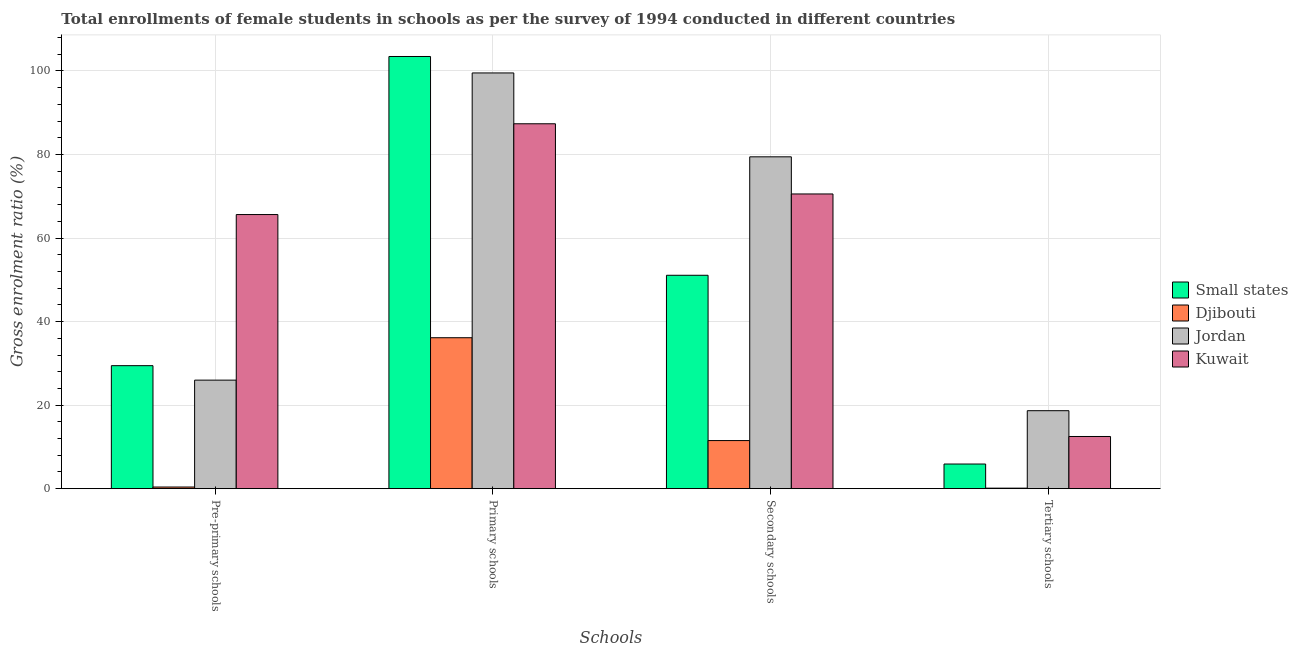How many different coloured bars are there?
Your response must be concise. 4. How many groups of bars are there?
Your response must be concise. 4. Are the number of bars on each tick of the X-axis equal?
Keep it short and to the point. Yes. What is the label of the 2nd group of bars from the left?
Your answer should be very brief. Primary schools. What is the gross enrolment ratio(female) in secondary schools in Kuwait?
Your response must be concise. 70.55. Across all countries, what is the maximum gross enrolment ratio(female) in primary schools?
Give a very brief answer. 103.46. Across all countries, what is the minimum gross enrolment ratio(female) in primary schools?
Ensure brevity in your answer.  36.14. In which country was the gross enrolment ratio(female) in tertiary schools maximum?
Give a very brief answer. Jordan. In which country was the gross enrolment ratio(female) in tertiary schools minimum?
Offer a very short reply. Djibouti. What is the total gross enrolment ratio(female) in pre-primary schools in the graph?
Offer a terse response. 121.45. What is the difference between the gross enrolment ratio(female) in secondary schools in Jordan and that in Kuwait?
Provide a short and direct response. 8.89. What is the difference between the gross enrolment ratio(female) in pre-primary schools in Small states and the gross enrolment ratio(female) in secondary schools in Kuwait?
Ensure brevity in your answer.  -41.11. What is the average gross enrolment ratio(female) in pre-primary schools per country?
Offer a terse response. 30.36. What is the difference between the gross enrolment ratio(female) in pre-primary schools and gross enrolment ratio(female) in secondary schools in Djibouti?
Give a very brief answer. -11.12. What is the ratio of the gross enrolment ratio(female) in primary schools in Kuwait to that in Small states?
Keep it short and to the point. 0.84. Is the gross enrolment ratio(female) in primary schools in Kuwait less than that in Djibouti?
Give a very brief answer. No. Is the difference between the gross enrolment ratio(female) in tertiary schools in Kuwait and Djibouti greater than the difference between the gross enrolment ratio(female) in pre-primary schools in Kuwait and Djibouti?
Your answer should be very brief. No. What is the difference between the highest and the second highest gross enrolment ratio(female) in tertiary schools?
Your answer should be very brief. 6.18. What is the difference between the highest and the lowest gross enrolment ratio(female) in primary schools?
Your answer should be compact. 67.33. In how many countries, is the gross enrolment ratio(female) in secondary schools greater than the average gross enrolment ratio(female) in secondary schools taken over all countries?
Provide a succinct answer. 2. Is the sum of the gross enrolment ratio(female) in secondary schools in Jordan and Kuwait greater than the maximum gross enrolment ratio(female) in primary schools across all countries?
Keep it short and to the point. Yes. What does the 1st bar from the left in Primary schools represents?
Provide a succinct answer. Small states. What does the 1st bar from the right in Primary schools represents?
Your response must be concise. Kuwait. How many bars are there?
Your response must be concise. 16. Are all the bars in the graph horizontal?
Ensure brevity in your answer.  No. Does the graph contain any zero values?
Offer a very short reply. No. Does the graph contain grids?
Offer a very short reply. Yes. How are the legend labels stacked?
Offer a very short reply. Vertical. What is the title of the graph?
Make the answer very short. Total enrollments of female students in schools as per the survey of 1994 conducted in different countries. What is the label or title of the X-axis?
Make the answer very short. Schools. What is the Gross enrolment ratio (%) of Small states in Pre-primary schools?
Offer a very short reply. 29.45. What is the Gross enrolment ratio (%) in Djibouti in Pre-primary schools?
Give a very brief answer. 0.4. What is the Gross enrolment ratio (%) of Jordan in Pre-primary schools?
Offer a terse response. 25.98. What is the Gross enrolment ratio (%) of Kuwait in Pre-primary schools?
Your response must be concise. 65.62. What is the Gross enrolment ratio (%) in Small states in Primary schools?
Your response must be concise. 103.46. What is the Gross enrolment ratio (%) of Djibouti in Primary schools?
Give a very brief answer. 36.14. What is the Gross enrolment ratio (%) in Jordan in Primary schools?
Your answer should be compact. 99.53. What is the Gross enrolment ratio (%) of Kuwait in Primary schools?
Your response must be concise. 87.36. What is the Gross enrolment ratio (%) in Small states in Secondary schools?
Make the answer very short. 51.09. What is the Gross enrolment ratio (%) of Djibouti in Secondary schools?
Offer a terse response. 11.52. What is the Gross enrolment ratio (%) in Jordan in Secondary schools?
Give a very brief answer. 79.44. What is the Gross enrolment ratio (%) in Kuwait in Secondary schools?
Your answer should be compact. 70.55. What is the Gross enrolment ratio (%) of Small states in Tertiary schools?
Provide a short and direct response. 5.9. What is the Gross enrolment ratio (%) of Djibouti in Tertiary schools?
Offer a terse response. 0.13. What is the Gross enrolment ratio (%) of Jordan in Tertiary schools?
Ensure brevity in your answer.  18.67. What is the Gross enrolment ratio (%) in Kuwait in Tertiary schools?
Your answer should be very brief. 12.49. Across all Schools, what is the maximum Gross enrolment ratio (%) in Small states?
Your answer should be very brief. 103.46. Across all Schools, what is the maximum Gross enrolment ratio (%) of Djibouti?
Give a very brief answer. 36.14. Across all Schools, what is the maximum Gross enrolment ratio (%) of Jordan?
Keep it short and to the point. 99.53. Across all Schools, what is the maximum Gross enrolment ratio (%) of Kuwait?
Your response must be concise. 87.36. Across all Schools, what is the minimum Gross enrolment ratio (%) in Small states?
Offer a terse response. 5.9. Across all Schools, what is the minimum Gross enrolment ratio (%) in Djibouti?
Provide a succinct answer. 0.13. Across all Schools, what is the minimum Gross enrolment ratio (%) in Jordan?
Your answer should be very brief. 18.67. Across all Schools, what is the minimum Gross enrolment ratio (%) in Kuwait?
Offer a terse response. 12.49. What is the total Gross enrolment ratio (%) of Small states in the graph?
Provide a succinct answer. 189.9. What is the total Gross enrolment ratio (%) in Djibouti in the graph?
Offer a very short reply. 48.17. What is the total Gross enrolment ratio (%) in Jordan in the graph?
Keep it short and to the point. 223.62. What is the total Gross enrolment ratio (%) of Kuwait in the graph?
Offer a terse response. 236.03. What is the difference between the Gross enrolment ratio (%) of Small states in Pre-primary schools and that in Primary schools?
Offer a very short reply. -74.02. What is the difference between the Gross enrolment ratio (%) in Djibouti in Pre-primary schools and that in Primary schools?
Your answer should be compact. -35.74. What is the difference between the Gross enrolment ratio (%) in Jordan in Pre-primary schools and that in Primary schools?
Provide a short and direct response. -73.54. What is the difference between the Gross enrolment ratio (%) of Kuwait in Pre-primary schools and that in Primary schools?
Offer a terse response. -21.73. What is the difference between the Gross enrolment ratio (%) of Small states in Pre-primary schools and that in Secondary schools?
Your response must be concise. -21.64. What is the difference between the Gross enrolment ratio (%) in Djibouti in Pre-primary schools and that in Secondary schools?
Ensure brevity in your answer.  -11.12. What is the difference between the Gross enrolment ratio (%) of Jordan in Pre-primary schools and that in Secondary schools?
Your answer should be very brief. -53.46. What is the difference between the Gross enrolment ratio (%) in Kuwait in Pre-primary schools and that in Secondary schools?
Offer a very short reply. -4.93. What is the difference between the Gross enrolment ratio (%) of Small states in Pre-primary schools and that in Tertiary schools?
Make the answer very short. 23.55. What is the difference between the Gross enrolment ratio (%) in Djibouti in Pre-primary schools and that in Tertiary schools?
Your answer should be very brief. 0.27. What is the difference between the Gross enrolment ratio (%) of Jordan in Pre-primary schools and that in Tertiary schools?
Your answer should be compact. 7.32. What is the difference between the Gross enrolment ratio (%) in Kuwait in Pre-primary schools and that in Tertiary schools?
Provide a succinct answer. 53.13. What is the difference between the Gross enrolment ratio (%) in Small states in Primary schools and that in Secondary schools?
Your answer should be compact. 52.38. What is the difference between the Gross enrolment ratio (%) in Djibouti in Primary schools and that in Secondary schools?
Give a very brief answer. 24.62. What is the difference between the Gross enrolment ratio (%) of Jordan in Primary schools and that in Secondary schools?
Keep it short and to the point. 20.08. What is the difference between the Gross enrolment ratio (%) in Kuwait in Primary schools and that in Secondary schools?
Make the answer very short. 16.8. What is the difference between the Gross enrolment ratio (%) of Small states in Primary schools and that in Tertiary schools?
Provide a succinct answer. 97.56. What is the difference between the Gross enrolment ratio (%) in Djibouti in Primary schools and that in Tertiary schools?
Your response must be concise. 36.01. What is the difference between the Gross enrolment ratio (%) in Jordan in Primary schools and that in Tertiary schools?
Offer a terse response. 80.86. What is the difference between the Gross enrolment ratio (%) in Kuwait in Primary schools and that in Tertiary schools?
Keep it short and to the point. 74.87. What is the difference between the Gross enrolment ratio (%) of Small states in Secondary schools and that in Tertiary schools?
Your answer should be very brief. 45.19. What is the difference between the Gross enrolment ratio (%) in Djibouti in Secondary schools and that in Tertiary schools?
Offer a terse response. 11.39. What is the difference between the Gross enrolment ratio (%) in Jordan in Secondary schools and that in Tertiary schools?
Ensure brevity in your answer.  60.78. What is the difference between the Gross enrolment ratio (%) in Kuwait in Secondary schools and that in Tertiary schools?
Offer a terse response. 58.06. What is the difference between the Gross enrolment ratio (%) in Small states in Pre-primary schools and the Gross enrolment ratio (%) in Djibouti in Primary schools?
Ensure brevity in your answer.  -6.69. What is the difference between the Gross enrolment ratio (%) in Small states in Pre-primary schools and the Gross enrolment ratio (%) in Jordan in Primary schools?
Give a very brief answer. -70.08. What is the difference between the Gross enrolment ratio (%) in Small states in Pre-primary schools and the Gross enrolment ratio (%) in Kuwait in Primary schools?
Offer a very short reply. -57.91. What is the difference between the Gross enrolment ratio (%) of Djibouti in Pre-primary schools and the Gross enrolment ratio (%) of Jordan in Primary schools?
Offer a very short reply. -99.13. What is the difference between the Gross enrolment ratio (%) in Djibouti in Pre-primary schools and the Gross enrolment ratio (%) in Kuwait in Primary schools?
Make the answer very short. -86.96. What is the difference between the Gross enrolment ratio (%) of Jordan in Pre-primary schools and the Gross enrolment ratio (%) of Kuwait in Primary schools?
Give a very brief answer. -61.37. What is the difference between the Gross enrolment ratio (%) in Small states in Pre-primary schools and the Gross enrolment ratio (%) in Djibouti in Secondary schools?
Keep it short and to the point. 17.93. What is the difference between the Gross enrolment ratio (%) of Small states in Pre-primary schools and the Gross enrolment ratio (%) of Jordan in Secondary schools?
Your answer should be very brief. -50. What is the difference between the Gross enrolment ratio (%) in Small states in Pre-primary schools and the Gross enrolment ratio (%) in Kuwait in Secondary schools?
Your answer should be very brief. -41.11. What is the difference between the Gross enrolment ratio (%) in Djibouti in Pre-primary schools and the Gross enrolment ratio (%) in Jordan in Secondary schools?
Your answer should be very brief. -79.05. What is the difference between the Gross enrolment ratio (%) in Djibouti in Pre-primary schools and the Gross enrolment ratio (%) in Kuwait in Secondary schools?
Make the answer very short. -70.16. What is the difference between the Gross enrolment ratio (%) in Jordan in Pre-primary schools and the Gross enrolment ratio (%) in Kuwait in Secondary schools?
Your answer should be very brief. -44.57. What is the difference between the Gross enrolment ratio (%) of Small states in Pre-primary schools and the Gross enrolment ratio (%) of Djibouti in Tertiary schools?
Offer a terse response. 29.32. What is the difference between the Gross enrolment ratio (%) of Small states in Pre-primary schools and the Gross enrolment ratio (%) of Jordan in Tertiary schools?
Keep it short and to the point. 10.78. What is the difference between the Gross enrolment ratio (%) in Small states in Pre-primary schools and the Gross enrolment ratio (%) in Kuwait in Tertiary schools?
Your answer should be very brief. 16.96. What is the difference between the Gross enrolment ratio (%) of Djibouti in Pre-primary schools and the Gross enrolment ratio (%) of Jordan in Tertiary schools?
Give a very brief answer. -18.27. What is the difference between the Gross enrolment ratio (%) in Djibouti in Pre-primary schools and the Gross enrolment ratio (%) in Kuwait in Tertiary schools?
Provide a short and direct response. -12.1. What is the difference between the Gross enrolment ratio (%) of Jordan in Pre-primary schools and the Gross enrolment ratio (%) of Kuwait in Tertiary schools?
Ensure brevity in your answer.  13.49. What is the difference between the Gross enrolment ratio (%) of Small states in Primary schools and the Gross enrolment ratio (%) of Djibouti in Secondary schools?
Your answer should be very brief. 91.95. What is the difference between the Gross enrolment ratio (%) in Small states in Primary schools and the Gross enrolment ratio (%) in Jordan in Secondary schools?
Make the answer very short. 24.02. What is the difference between the Gross enrolment ratio (%) of Small states in Primary schools and the Gross enrolment ratio (%) of Kuwait in Secondary schools?
Provide a succinct answer. 32.91. What is the difference between the Gross enrolment ratio (%) of Djibouti in Primary schools and the Gross enrolment ratio (%) of Jordan in Secondary schools?
Give a very brief answer. -43.31. What is the difference between the Gross enrolment ratio (%) of Djibouti in Primary schools and the Gross enrolment ratio (%) of Kuwait in Secondary schools?
Ensure brevity in your answer.  -34.42. What is the difference between the Gross enrolment ratio (%) in Jordan in Primary schools and the Gross enrolment ratio (%) in Kuwait in Secondary schools?
Offer a terse response. 28.97. What is the difference between the Gross enrolment ratio (%) in Small states in Primary schools and the Gross enrolment ratio (%) in Djibouti in Tertiary schools?
Your answer should be compact. 103.34. What is the difference between the Gross enrolment ratio (%) of Small states in Primary schools and the Gross enrolment ratio (%) of Jordan in Tertiary schools?
Your response must be concise. 84.8. What is the difference between the Gross enrolment ratio (%) of Small states in Primary schools and the Gross enrolment ratio (%) of Kuwait in Tertiary schools?
Provide a short and direct response. 90.97. What is the difference between the Gross enrolment ratio (%) of Djibouti in Primary schools and the Gross enrolment ratio (%) of Jordan in Tertiary schools?
Provide a succinct answer. 17.47. What is the difference between the Gross enrolment ratio (%) in Djibouti in Primary schools and the Gross enrolment ratio (%) in Kuwait in Tertiary schools?
Give a very brief answer. 23.65. What is the difference between the Gross enrolment ratio (%) of Jordan in Primary schools and the Gross enrolment ratio (%) of Kuwait in Tertiary schools?
Ensure brevity in your answer.  87.03. What is the difference between the Gross enrolment ratio (%) of Small states in Secondary schools and the Gross enrolment ratio (%) of Djibouti in Tertiary schools?
Make the answer very short. 50.96. What is the difference between the Gross enrolment ratio (%) in Small states in Secondary schools and the Gross enrolment ratio (%) in Jordan in Tertiary schools?
Your response must be concise. 32.42. What is the difference between the Gross enrolment ratio (%) in Small states in Secondary schools and the Gross enrolment ratio (%) in Kuwait in Tertiary schools?
Provide a short and direct response. 38.6. What is the difference between the Gross enrolment ratio (%) of Djibouti in Secondary schools and the Gross enrolment ratio (%) of Jordan in Tertiary schools?
Your answer should be very brief. -7.15. What is the difference between the Gross enrolment ratio (%) of Djibouti in Secondary schools and the Gross enrolment ratio (%) of Kuwait in Tertiary schools?
Your answer should be compact. -0.97. What is the difference between the Gross enrolment ratio (%) in Jordan in Secondary schools and the Gross enrolment ratio (%) in Kuwait in Tertiary schools?
Give a very brief answer. 66.95. What is the average Gross enrolment ratio (%) in Small states per Schools?
Offer a terse response. 47.48. What is the average Gross enrolment ratio (%) in Djibouti per Schools?
Your answer should be compact. 12.04. What is the average Gross enrolment ratio (%) of Jordan per Schools?
Make the answer very short. 55.91. What is the average Gross enrolment ratio (%) in Kuwait per Schools?
Ensure brevity in your answer.  59.01. What is the difference between the Gross enrolment ratio (%) of Small states and Gross enrolment ratio (%) of Djibouti in Pre-primary schools?
Give a very brief answer. 29.05. What is the difference between the Gross enrolment ratio (%) in Small states and Gross enrolment ratio (%) in Jordan in Pre-primary schools?
Offer a terse response. 3.46. What is the difference between the Gross enrolment ratio (%) in Small states and Gross enrolment ratio (%) in Kuwait in Pre-primary schools?
Your response must be concise. -36.18. What is the difference between the Gross enrolment ratio (%) of Djibouti and Gross enrolment ratio (%) of Jordan in Pre-primary schools?
Offer a very short reply. -25.59. What is the difference between the Gross enrolment ratio (%) of Djibouti and Gross enrolment ratio (%) of Kuwait in Pre-primary schools?
Your response must be concise. -65.23. What is the difference between the Gross enrolment ratio (%) of Jordan and Gross enrolment ratio (%) of Kuwait in Pre-primary schools?
Make the answer very short. -39.64. What is the difference between the Gross enrolment ratio (%) in Small states and Gross enrolment ratio (%) in Djibouti in Primary schools?
Ensure brevity in your answer.  67.33. What is the difference between the Gross enrolment ratio (%) in Small states and Gross enrolment ratio (%) in Jordan in Primary schools?
Ensure brevity in your answer.  3.94. What is the difference between the Gross enrolment ratio (%) of Small states and Gross enrolment ratio (%) of Kuwait in Primary schools?
Offer a very short reply. 16.11. What is the difference between the Gross enrolment ratio (%) of Djibouti and Gross enrolment ratio (%) of Jordan in Primary schools?
Provide a short and direct response. -63.39. What is the difference between the Gross enrolment ratio (%) in Djibouti and Gross enrolment ratio (%) in Kuwait in Primary schools?
Your answer should be very brief. -51.22. What is the difference between the Gross enrolment ratio (%) in Jordan and Gross enrolment ratio (%) in Kuwait in Primary schools?
Offer a terse response. 12.17. What is the difference between the Gross enrolment ratio (%) of Small states and Gross enrolment ratio (%) of Djibouti in Secondary schools?
Make the answer very short. 39.57. What is the difference between the Gross enrolment ratio (%) of Small states and Gross enrolment ratio (%) of Jordan in Secondary schools?
Your response must be concise. -28.36. What is the difference between the Gross enrolment ratio (%) of Small states and Gross enrolment ratio (%) of Kuwait in Secondary schools?
Keep it short and to the point. -19.47. What is the difference between the Gross enrolment ratio (%) of Djibouti and Gross enrolment ratio (%) of Jordan in Secondary schools?
Make the answer very short. -67.93. What is the difference between the Gross enrolment ratio (%) in Djibouti and Gross enrolment ratio (%) in Kuwait in Secondary schools?
Offer a terse response. -59.04. What is the difference between the Gross enrolment ratio (%) of Jordan and Gross enrolment ratio (%) of Kuwait in Secondary schools?
Provide a short and direct response. 8.89. What is the difference between the Gross enrolment ratio (%) of Small states and Gross enrolment ratio (%) of Djibouti in Tertiary schools?
Your response must be concise. 5.78. What is the difference between the Gross enrolment ratio (%) of Small states and Gross enrolment ratio (%) of Jordan in Tertiary schools?
Make the answer very short. -12.77. What is the difference between the Gross enrolment ratio (%) in Small states and Gross enrolment ratio (%) in Kuwait in Tertiary schools?
Provide a short and direct response. -6.59. What is the difference between the Gross enrolment ratio (%) of Djibouti and Gross enrolment ratio (%) of Jordan in Tertiary schools?
Keep it short and to the point. -18.54. What is the difference between the Gross enrolment ratio (%) of Djibouti and Gross enrolment ratio (%) of Kuwait in Tertiary schools?
Make the answer very short. -12.37. What is the difference between the Gross enrolment ratio (%) in Jordan and Gross enrolment ratio (%) in Kuwait in Tertiary schools?
Provide a short and direct response. 6.18. What is the ratio of the Gross enrolment ratio (%) in Small states in Pre-primary schools to that in Primary schools?
Keep it short and to the point. 0.28. What is the ratio of the Gross enrolment ratio (%) of Djibouti in Pre-primary schools to that in Primary schools?
Ensure brevity in your answer.  0.01. What is the ratio of the Gross enrolment ratio (%) of Jordan in Pre-primary schools to that in Primary schools?
Provide a succinct answer. 0.26. What is the ratio of the Gross enrolment ratio (%) of Kuwait in Pre-primary schools to that in Primary schools?
Offer a very short reply. 0.75. What is the ratio of the Gross enrolment ratio (%) of Small states in Pre-primary schools to that in Secondary schools?
Provide a succinct answer. 0.58. What is the ratio of the Gross enrolment ratio (%) in Djibouti in Pre-primary schools to that in Secondary schools?
Make the answer very short. 0.03. What is the ratio of the Gross enrolment ratio (%) in Jordan in Pre-primary schools to that in Secondary schools?
Keep it short and to the point. 0.33. What is the ratio of the Gross enrolment ratio (%) of Kuwait in Pre-primary schools to that in Secondary schools?
Keep it short and to the point. 0.93. What is the ratio of the Gross enrolment ratio (%) in Small states in Pre-primary schools to that in Tertiary schools?
Offer a terse response. 4.99. What is the ratio of the Gross enrolment ratio (%) of Djibouti in Pre-primary schools to that in Tertiary schools?
Your answer should be compact. 3.15. What is the ratio of the Gross enrolment ratio (%) of Jordan in Pre-primary schools to that in Tertiary schools?
Offer a terse response. 1.39. What is the ratio of the Gross enrolment ratio (%) of Kuwait in Pre-primary schools to that in Tertiary schools?
Keep it short and to the point. 5.25. What is the ratio of the Gross enrolment ratio (%) in Small states in Primary schools to that in Secondary schools?
Offer a terse response. 2.03. What is the ratio of the Gross enrolment ratio (%) in Djibouti in Primary schools to that in Secondary schools?
Ensure brevity in your answer.  3.14. What is the ratio of the Gross enrolment ratio (%) of Jordan in Primary schools to that in Secondary schools?
Offer a terse response. 1.25. What is the ratio of the Gross enrolment ratio (%) of Kuwait in Primary schools to that in Secondary schools?
Provide a succinct answer. 1.24. What is the ratio of the Gross enrolment ratio (%) of Small states in Primary schools to that in Tertiary schools?
Your answer should be compact. 17.53. What is the ratio of the Gross enrolment ratio (%) in Djibouti in Primary schools to that in Tertiary schools?
Ensure brevity in your answer.  288.29. What is the ratio of the Gross enrolment ratio (%) in Jordan in Primary schools to that in Tertiary schools?
Your answer should be compact. 5.33. What is the ratio of the Gross enrolment ratio (%) of Kuwait in Primary schools to that in Tertiary schools?
Your answer should be very brief. 6.99. What is the ratio of the Gross enrolment ratio (%) of Small states in Secondary schools to that in Tertiary schools?
Ensure brevity in your answer.  8.66. What is the ratio of the Gross enrolment ratio (%) of Djibouti in Secondary schools to that in Tertiary schools?
Your answer should be compact. 91.88. What is the ratio of the Gross enrolment ratio (%) in Jordan in Secondary schools to that in Tertiary schools?
Give a very brief answer. 4.26. What is the ratio of the Gross enrolment ratio (%) of Kuwait in Secondary schools to that in Tertiary schools?
Offer a terse response. 5.65. What is the difference between the highest and the second highest Gross enrolment ratio (%) of Small states?
Offer a terse response. 52.38. What is the difference between the highest and the second highest Gross enrolment ratio (%) of Djibouti?
Give a very brief answer. 24.62. What is the difference between the highest and the second highest Gross enrolment ratio (%) of Jordan?
Ensure brevity in your answer.  20.08. What is the difference between the highest and the second highest Gross enrolment ratio (%) of Kuwait?
Offer a very short reply. 16.8. What is the difference between the highest and the lowest Gross enrolment ratio (%) of Small states?
Give a very brief answer. 97.56. What is the difference between the highest and the lowest Gross enrolment ratio (%) of Djibouti?
Your answer should be very brief. 36.01. What is the difference between the highest and the lowest Gross enrolment ratio (%) of Jordan?
Your response must be concise. 80.86. What is the difference between the highest and the lowest Gross enrolment ratio (%) in Kuwait?
Your answer should be very brief. 74.87. 